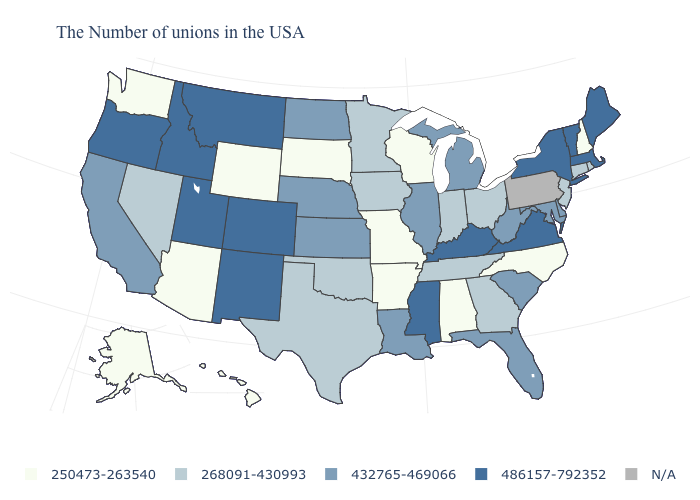Name the states that have a value in the range 250473-263540?
Keep it brief. New Hampshire, North Carolina, Alabama, Wisconsin, Missouri, Arkansas, South Dakota, Wyoming, Arizona, Washington, Alaska, Hawaii. What is the value of Iowa?
Give a very brief answer. 268091-430993. Name the states that have a value in the range N/A?
Give a very brief answer. Pennsylvania. What is the value of Nebraska?
Concise answer only. 432765-469066. Which states have the lowest value in the USA?
Short answer required. New Hampshire, North Carolina, Alabama, Wisconsin, Missouri, Arkansas, South Dakota, Wyoming, Arizona, Washington, Alaska, Hawaii. What is the value of New Jersey?
Answer briefly. 268091-430993. Name the states that have a value in the range N/A?
Short answer required. Pennsylvania. Name the states that have a value in the range 250473-263540?
Short answer required. New Hampshire, North Carolina, Alabama, Wisconsin, Missouri, Arkansas, South Dakota, Wyoming, Arizona, Washington, Alaska, Hawaii. What is the value of Oregon?
Answer briefly. 486157-792352. Among the states that border Colorado , which have the lowest value?
Give a very brief answer. Wyoming, Arizona. What is the value of Colorado?
Concise answer only. 486157-792352. What is the value of Illinois?
Short answer required. 432765-469066. Name the states that have a value in the range N/A?
Short answer required. Pennsylvania. Does Oregon have the highest value in the USA?
Give a very brief answer. Yes. 